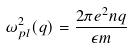Convert formula to latex. <formula><loc_0><loc_0><loc_500><loc_500>\omega _ { p l } ^ { 2 } ( q ) = \frac { 2 \pi e ^ { 2 } n q } { \epsilon m }</formula> 